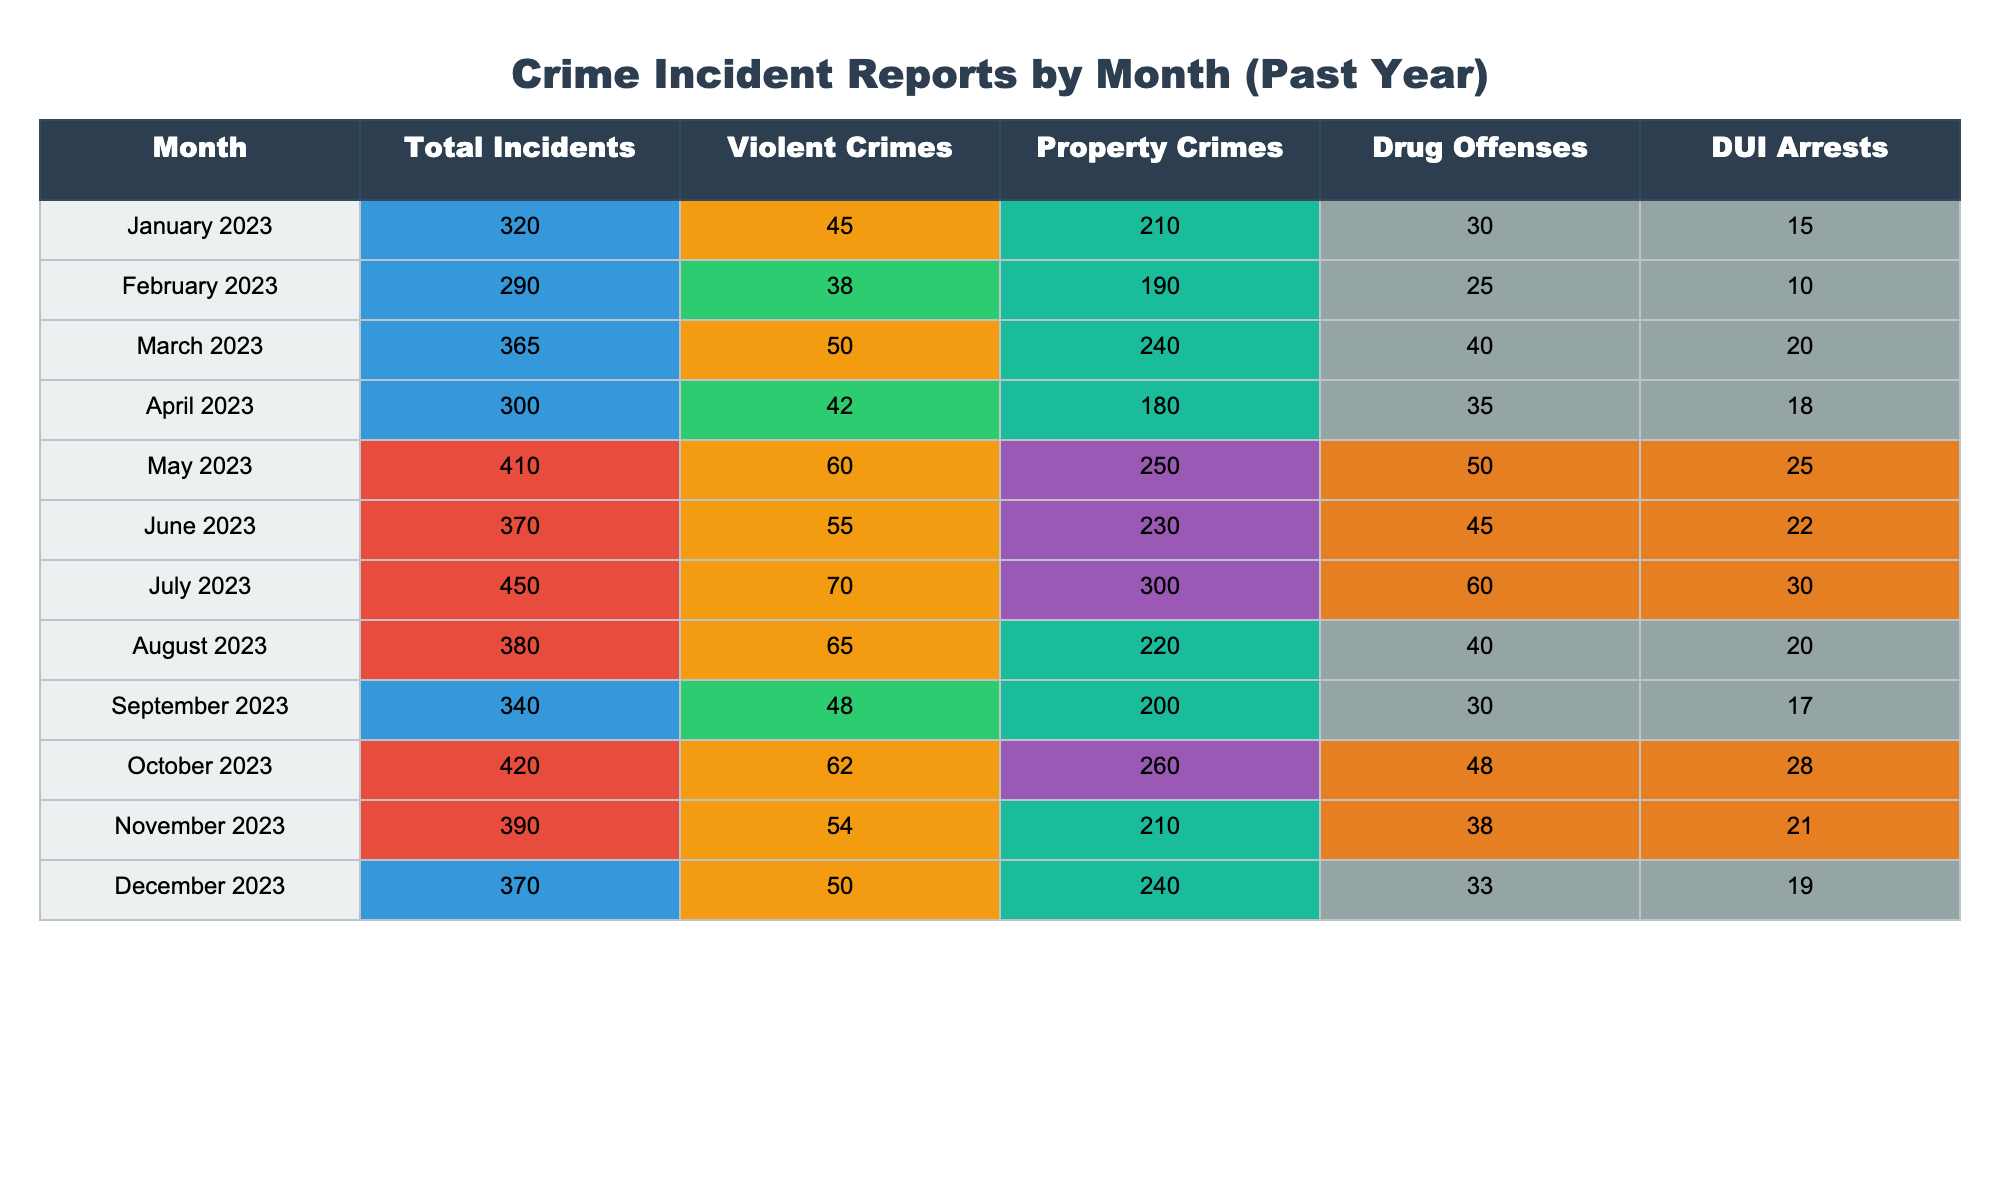What was the total number of incidents in July 2023? The table shows a total of 450 incidents listed under July 2023.
Answer: 450 How many violent crimes were reported in May 2023? In May 2023, the table indicates that there were 60 violent crimes recorded.
Answer: 60 Which month had the highest number of property crimes? By reviewing the property crimes column, July 2023 has the highest reported value of 300 property crimes.
Answer: July 2023 What is the average number of drug offenses from January to December 2023? To calculate the average, first sum the drug offenses from each month: (30 + 25 + 40 + 35 + 50 + 45 + 60 + 40 + 30 + 48 + 38 + 33) =  480. Then divide by the 12 months: 480 / 12 = 40.
Answer: 40 Was there a decrease in DUI arrests from May to June 2023? Comparing the DUI arrests for May (25) and June (22) shows a decrease of 3 arrests from May to June.
Answer: Yes In which month did drug offenses exceed 40? Looking through the drug offenses column, the months where drug offenses exceed 40 are: May (50), June (45), July (60), and October (48).
Answer: May, June, July, October Did the total incidents in December 2023 exceed those in September 2023? The total incidents for December (370) do not exceed those of September (340), as December is greater than September.
Answer: Yes Which month had the least number of violent crimes? By checking the values for violent crimes, February 2023 has the lowest number reported at 38 violent crimes.
Answer: February 2023 How many total incidents were recorded in the first half of 2023? To find this, sum the total incidents from January (320), February (290), March (365), April (300), May (410), and June (370): 320 + 290 + 365 + 300 + 410 + 370 = 2055.
Answer: 2055 